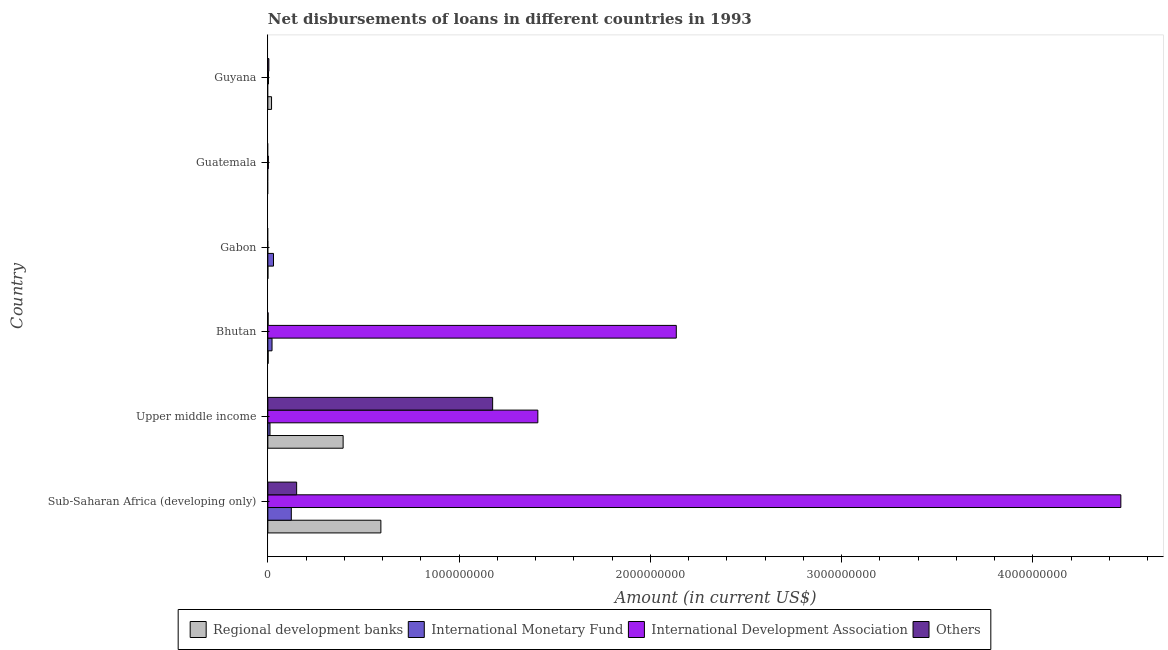How many bars are there on the 3rd tick from the top?
Ensure brevity in your answer.  2. How many bars are there on the 4th tick from the bottom?
Your response must be concise. 2. What is the label of the 2nd group of bars from the top?
Your answer should be compact. Guatemala. In how many cases, is the number of bars for a given country not equal to the number of legend labels?
Provide a short and direct response. 3. What is the amount of loan disimbursed by other organisations in Sub-Saharan Africa (developing only)?
Keep it short and to the point. 1.51e+08. Across all countries, what is the maximum amount of loan disimbursed by international development association?
Keep it short and to the point. 4.46e+09. In which country was the amount of loan disimbursed by regional development banks maximum?
Your answer should be compact. Sub-Saharan Africa (developing only). What is the total amount of loan disimbursed by other organisations in the graph?
Make the answer very short. 1.33e+09. What is the difference between the amount of loan disimbursed by international development association in Bhutan and that in Upper middle income?
Offer a terse response. 7.24e+08. What is the difference between the amount of loan disimbursed by other organisations in Bhutan and the amount of loan disimbursed by regional development banks in Guyana?
Your response must be concise. -1.81e+07. What is the average amount of loan disimbursed by other organisations per country?
Make the answer very short. 2.22e+08. What is the difference between the amount of loan disimbursed by regional development banks and amount of loan disimbursed by international development association in Guyana?
Give a very brief answer. 1.60e+07. In how many countries, is the amount of loan disimbursed by international development association greater than 4000000000 US$?
Provide a short and direct response. 1. What is the ratio of the amount of loan disimbursed by international monetary fund in Bhutan to that in Sub-Saharan Africa (developing only)?
Provide a short and direct response. 0.18. Is the amount of loan disimbursed by other organisations in Bhutan less than that in Guyana?
Offer a very short reply. Yes. What is the difference between the highest and the second highest amount of loan disimbursed by international monetary fund?
Your answer should be very brief. 9.31e+07. What is the difference between the highest and the lowest amount of loan disimbursed by international monetary fund?
Ensure brevity in your answer.  1.23e+08. In how many countries, is the amount of loan disimbursed by other organisations greater than the average amount of loan disimbursed by other organisations taken over all countries?
Your answer should be very brief. 1. Is the sum of the amount of loan disimbursed by regional development banks in Gabon and Sub-Saharan Africa (developing only) greater than the maximum amount of loan disimbursed by international monetary fund across all countries?
Your answer should be compact. Yes. Is it the case that in every country, the sum of the amount of loan disimbursed by regional development banks and amount of loan disimbursed by international monetary fund is greater than the amount of loan disimbursed by international development association?
Offer a very short reply. No. What is the difference between two consecutive major ticks on the X-axis?
Ensure brevity in your answer.  1.00e+09. Are the values on the major ticks of X-axis written in scientific E-notation?
Keep it short and to the point. No. Does the graph contain any zero values?
Provide a short and direct response. Yes. Does the graph contain grids?
Your answer should be very brief. No. What is the title of the graph?
Your response must be concise. Net disbursements of loans in different countries in 1993. What is the label or title of the Y-axis?
Your answer should be compact. Country. What is the Amount (in current US$) of Regional development banks in Sub-Saharan Africa (developing only)?
Keep it short and to the point. 5.91e+08. What is the Amount (in current US$) in International Monetary Fund in Sub-Saharan Africa (developing only)?
Make the answer very short. 1.23e+08. What is the Amount (in current US$) in International Development Association in Sub-Saharan Africa (developing only)?
Your response must be concise. 4.46e+09. What is the Amount (in current US$) of Others in Sub-Saharan Africa (developing only)?
Ensure brevity in your answer.  1.51e+08. What is the Amount (in current US$) in Regional development banks in Upper middle income?
Make the answer very short. 3.94e+08. What is the Amount (in current US$) of International Monetary Fund in Upper middle income?
Ensure brevity in your answer.  1.13e+07. What is the Amount (in current US$) of International Development Association in Upper middle income?
Give a very brief answer. 1.41e+09. What is the Amount (in current US$) in Others in Upper middle income?
Offer a very short reply. 1.18e+09. What is the Amount (in current US$) of Regional development banks in Bhutan?
Give a very brief answer. 1.58e+06. What is the Amount (in current US$) in International Monetary Fund in Bhutan?
Offer a very short reply. 2.19e+07. What is the Amount (in current US$) in International Development Association in Bhutan?
Give a very brief answer. 2.14e+09. What is the Amount (in current US$) in Others in Bhutan?
Give a very brief answer. 1.32e+06. What is the Amount (in current US$) in Regional development banks in Gabon?
Offer a terse response. 1.06e+05. What is the Amount (in current US$) in International Monetary Fund in Gabon?
Keep it short and to the point. 2.96e+07. What is the Amount (in current US$) in International Development Association in Gabon?
Your response must be concise. 0. What is the Amount (in current US$) in Others in Gabon?
Provide a succinct answer. 0. What is the Amount (in current US$) of Regional development banks in Guatemala?
Your response must be concise. 0. What is the Amount (in current US$) in International Monetary Fund in Guatemala?
Make the answer very short. 0. What is the Amount (in current US$) in International Development Association in Guatemala?
Give a very brief answer. 2.72e+06. What is the Amount (in current US$) in Others in Guatemala?
Offer a very short reply. 0. What is the Amount (in current US$) in Regional development banks in Guyana?
Make the answer very short. 1.94e+07. What is the Amount (in current US$) in International Development Association in Guyana?
Give a very brief answer. 3.42e+06. What is the Amount (in current US$) of Others in Guyana?
Provide a short and direct response. 5.28e+06. Across all countries, what is the maximum Amount (in current US$) in Regional development banks?
Provide a succinct answer. 5.91e+08. Across all countries, what is the maximum Amount (in current US$) of International Monetary Fund?
Make the answer very short. 1.23e+08. Across all countries, what is the maximum Amount (in current US$) in International Development Association?
Provide a short and direct response. 4.46e+09. Across all countries, what is the maximum Amount (in current US$) of Others?
Offer a very short reply. 1.18e+09. Across all countries, what is the minimum Amount (in current US$) in Others?
Offer a very short reply. 0. What is the total Amount (in current US$) of Regional development banks in the graph?
Your answer should be very brief. 1.01e+09. What is the total Amount (in current US$) in International Monetary Fund in the graph?
Make the answer very short. 1.85e+08. What is the total Amount (in current US$) of International Development Association in the graph?
Your answer should be very brief. 8.01e+09. What is the total Amount (in current US$) of Others in the graph?
Offer a very short reply. 1.33e+09. What is the difference between the Amount (in current US$) in Regional development banks in Sub-Saharan Africa (developing only) and that in Upper middle income?
Your answer should be compact. 1.97e+08. What is the difference between the Amount (in current US$) of International Monetary Fund in Sub-Saharan Africa (developing only) and that in Upper middle income?
Your answer should be compact. 1.11e+08. What is the difference between the Amount (in current US$) in International Development Association in Sub-Saharan Africa (developing only) and that in Upper middle income?
Your response must be concise. 3.05e+09. What is the difference between the Amount (in current US$) in Others in Sub-Saharan Africa (developing only) and that in Upper middle income?
Keep it short and to the point. -1.02e+09. What is the difference between the Amount (in current US$) of Regional development banks in Sub-Saharan Africa (developing only) and that in Bhutan?
Your answer should be compact. 5.89e+08. What is the difference between the Amount (in current US$) of International Monetary Fund in Sub-Saharan Africa (developing only) and that in Bhutan?
Your answer should be very brief. 1.01e+08. What is the difference between the Amount (in current US$) in International Development Association in Sub-Saharan Africa (developing only) and that in Bhutan?
Provide a short and direct response. 2.32e+09. What is the difference between the Amount (in current US$) of Others in Sub-Saharan Africa (developing only) and that in Bhutan?
Offer a terse response. 1.49e+08. What is the difference between the Amount (in current US$) of Regional development banks in Sub-Saharan Africa (developing only) and that in Gabon?
Keep it short and to the point. 5.91e+08. What is the difference between the Amount (in current US$) in International Monetary Fund in Sub-Saharan Africa (developing only) and that in Gabon?
Offer a very short reply. 9.31e+07. What is the difference between the Amount (in current US$) of International Development Association in Sub-Saharan Africa (developing only) and that in Guatemala?
Ensure brevity in your answer.  4.46e+09. What is the difference between the Amount (in current US$) in Regional development banks in Sub-Saharan Africa (developing only) and that in Guyana?
Offer a terse response. 5.72e+08. What is the difference between the Amount (in current US$) in International Development Association in Sub-Saharan Africa (developing only) and that in Guyana?
Your answer should be very brief. 4.46e+09. What is the difference between the Amount (in current US$) in Others in Sub-Saharan Africa (developing only) and that in Guyana?
Make the answer very short. 1.45e+08. What is the difference between the Amount (in current US$) in Regional development banks in Upper middle income and that in Bhutan?
Provide a short and direct response. 3.92e+08. What is the difference between the Amount (in current US$) in International Monetary Fund in Upper middle income and that in Bhutan?
Offer a terse response. -1.06e+07. What is the difference between the Amount (in current US$) of International Development Association in Upper middle income and that in Bhutan?
Provide a short and direct response. -7.24e+08. What is the difference between the Amount (in current US$) in Others in Upper middle income and that in Bhutan?
Provide a succinct answer. 1.17e+09. What is the difference between the Amount (in current US$) of Regional development banks in Upper middle income and that in Gabon?
Give a very brief answer. 3.93e+08. What is the difference between the Amount (in current US$) in International Monetary Fund in Upper middle income and that in Gabon?
Your response must be concise. -1.83e+07. What is the difference between the Amount (in current US$) in International Development Association in Upper middle income and that in Guatemala?
Your response must be concise. 1.41e+09. What is the difference between the Amount (in current US$) of Regional development banks in Upper middle income and that in Guyana?
Your answer should be very brief. 3.74e+08. What is the difference between the Amount (in current US$) in International Development Association in Upper middle income and that in Guyana?
Ensure brevity in your answer.  1.41e+09. What is the difference between the Amount (in current US$) in Others in Upper middle income and that in Guyana?
Offer a very short reply. 1.17e+09. What is the difference between the Amount (in current US$) in Regional development banks in Bhutan and that in Gabon?
Make the answer very short. 1.47e+06. What is the difference between the Amount (in current US$) in International Monetary Fund in Bhutan and that in Gabon?
Provide a short and direct response. -7.72e+06. What is the difference between the Amount (in current US$) in International Development Association in Bhutan and that in Guatemala?
Your answer should be very brief. 2.13e+09. What is the difference between the Amount (in current US$) in Regional development banks in Bhutan and that in Guyana?
Ensure brevity in your answer.  -1.78e+07. What is the difference between the Amount (in current US$) in International Development Association in Bhutan and that in Guyana?
Provide a short and direct response. 2.13e+09. What is the difference between the Amount (in current US$) of Others in Bhutan and that in Guyana?
Your answer should be very brief. -3.95e+06. What is the difference between the Amount (in current US$) of Regional development banks in Gabon and that in Guyana?
Offer a very short reply. -1.93e+07. What is the difference between the Amount (in current US$) in International Development Association in Guatemala and that in Guyana?
Make the answer very short. -6.98e+05. What is the difference between the Amount (in current US$) of Regional development banks in Sub-Saharan Africa (developing only) and the Amount (in current US$) of International Monetary Fund in Upper middle income?
Provide a succinct answer. 5.80e+08. What is the difference between the Amount (in current US$) of Regional development banks in Sub-Saharan Africa (developing only) and the Amount (in current US$) of International Development Association in Upper middle income?
Make the answer very short. -8.21e+08. What is the difference between the Amount (in current US$) in Regional development banks in Sub-Saharan Africa (developing only) and the Amount (in current US$) in Others in Upper middle income?
Make the answer very short. -5.84e+08. What is the difference between the Amount (in current US$) in International Monetary Fund in Sub-Saharan Africa (developing only) and the Amount (in current US$) in International Development Association in Upper middle income?
Provide a short and direct response. -1.29e+09. What is the difference between the Amount (in current US$) of International Monetary Fund in Sub-Saharan Africa (developing only) and the Amount (in current US$) of Others in Upper middle income?
Your response must be concise. -1.05e+09. What is the difference between the Amount (in current US$) in International Development Association in Sub-Saharan Africa (developing only) and the Amount (in current US$) in Others in Upper middle income?
Ensure brevity in your answer.  3.28e+09. What is the difference between the Amount (in current US$) of Regional development banks in Sub-Saharan Africa (developing only) and the Amount (in current US$) of International Monetary Fund in Bhutan?
Provide a succinct answer. 5.69e+08. What is the difference between the Amount (in current US$) in Regional development banks in Sub-Saharan Africa (developing only) and the Amount (in current US$) in International Development Association in Bhutan?
Provide a succinct answer. -1.54e+09. What is the difference between the Amount (in current US$) in Regional development banks in Sub-Saharan Africa (developing only) and the Amount (in current US$) in Others in Bhutan?
Offer a very short reply. 5.90e+08. What is the difference between the Amount (in current US$) in International Monetary Fund in Sub-Saharan Africa (developing only) and the Amount (in current US$) in International Development Association in Bhutan?
Ensure brevity in your answer.  -2.01e+09. What is the difference between the Amount (in current US$) in International Monetary Fund in Sub-Saharan Africa (developing only) and the Amount (in current US$) in Others in Bhutan?
Offer a terse response. 1.21e+08. What is the difference between the Amount (in current US$) in International Development Association in Sub-Saharan Africa (developing only) and the Amount (in current US$) in Others in Bhutan?
Ensure brevity in your answer.  4.46e+09. What is the difference between the Amount (in current US$) of Regional development banks in Sub-Saharan Africa (developing only) and the Amount (in current US$) of International Monetary Fund in Gabon?
Offer a very short reply. 5.61e+08. What is the difference between the Amount (in current US$) in Regional development banks in Sub-Saharan Africa (developing only) and the Amount (in current US$) in International Development Association in Guatemala?
Give a very brief answer. 5.88e+08. What is the difference between the Amount (in current US$) in International Monetary Fund in Sub-Saharan Africa (developing only) and the Amount (in current US$) in International Development Association in Guatemala?
Give a very brief answer. 1.20e+08. What is the difference between the Amount (in current US$) in Regional development banks in Sub-Saharan Africa (developing only) and the Amount (in current US$) in International Development Association in Guyana?
Your answer should be very brief. 5.88e+08. What is the difference between the Amount (in current US$) of Regional development banks in Sub-Saharan Africa (developing only) and the Amount (in current US$) of Others in Guyana?
Your answer should be compact. 5.86e+08. What is the difference between the Amount (in current US$) in International Monetary Fund in Sub-Saharan Africa (developing only) and the Amount (in current US$) in International Development Association in Guyana?
Make the answer very short. 1.19e+08. What is the difference between the Amount (in current US$) in International Monetary Fund in Sub-Saharan Africa (developing only) and the Amount (in current US$) in Others in Guyana?
Offer a very short reply. 1.17e+08. What is the difference between the Amount (in current US$) in International Development Association in Sub-Saharan Africa (developing only) and the Amount (in current US$) in Others in Guyana?
Your response must be concise. 4.45e+09. What is the difference between the Amount (in current US$) in Regional development banks in Upper middle income and the Amount (in current US$) in International Monetary Fund in Bhutan?
Offer a very short reply. 3.72e+08. What is the difference between the Amount (in current US$) in Regional development banks in Upper middle income and the Amount (in current US$) in International Development Association in Bhutan?
Provide a succinct answer. -1.74e+09. What is the difference between the Amount (in current US$) of Regional development banks in Upper middle income and the Amount (in current US$) of Others in Bhutan?
Ensure brevity in your answer.  3.92e+08. What is the difference between the Amount (in current US$) of International Monetary Fund in Upper middle income and the Amount (in current US$) of International Development Association in Bhutan?
Make the answer very short. -2.12e+09. What is the difference between the Amount (in current US$) of International Monetary Fund in Upper middle income and the Amount (in current US$) of Others in Bhutan?
Offer a terse response. 9.94e+06. What is the difference between the Amount (in current US$) in International Development Association in Upper middle income and the Amount (in current US$) in Others in Bhutan?
Make the answer very short. 1.41e+09. What is the difference between the Amount (in current US$) of Regional development banks in Upper middle income and the Amount (in current US$) of International Monetary Fund in Gabon?
Your answer should be very brief. 3.64e+08. What is the difference between the Amount (in current US$) of Regional development banks in Upper middle income and the Amount (in current US$) of International Development Association in Guatemala?
Your answer should be compact. 3.91e+08. What is the difference between the Amount (in current US$) in International Monetary Fund in Upper middle income and the Amount (in current US$) in International Development Association in Guatemala?
Give a very brief answer. 8.55e+06. What is the difference between the Amount (in current US$) of Regional development banks in Upper middle income and the Amount (in current US$) of International Development Association in Guyana?
Make the answer very short. 3.90e+08. What is the difference between the Amount (in current US$) in Regional development banks in Upper middle income and the Amount (in current US$) in Others in Guyana?
Provide a short and direct response. 3.88e+08. What is the difference between the Amount (in current US$) of International Monetary Fund in Upper middle income and the Amount (in current US$) of International Development Association in Guyana?
Ensure brevity in your answer.  7.85e+06. What is the difference between the Amount (in current US$) of International Monetary Fund in Upper middle income and the Amount (in current US$) of Others in Guyana?
Ensure brevity in your answer.  5.99e+06. What is the difference between the Amount (in current US$) in International Development Association in Upper middle income and the Amount (in current US$) in Others in Guyana?
Offer a terse response. 1.41e+09. What is the difference between the Amount (in current US$) of Regional development banks in Bhutan and the Amount (in current US$) of International Monetary Fund in Gabon?
Ensure brevity in your answer.  -2.80e+07. What is the difference between the Amount (in current US$) of Regional development banks in Bhutan and the Amount (in current US$) of International Development Association in Guatemala?
Offer a terse response. -1.14e+06. What is the difference between the Amount (in current US$) of International Monetary Fund in Bhutan and the Amount (in current US$) of International Development Association in Guatemala?
Provide a short and direct response. 1.91e+07. What is the difference between the Amount (in current US$) in Regional development banks in Bhutan and the Amount (in current US$) in International Development Association in Guyana?
Ensure brevity in your answer.  -1.84e+06. What is the difference between the Amount (in current US$) in Regional development banks in Bhutan and the Amount (in current US$) in Others in Guyana?
Offer a terse response. -3.70e+06. What is the difference between the Amount (in current US$) of International Monetary Fund in Bhutan and the Amount (in current US$) of International Development Association in Guyana?
Make the answer very short. 1.84e+07. What is the difference between the Amount (in current US$) in International Monetary Fund in Bhutan and the Amount (in current US$) in Others in Guyana?
Give a very brief answer. 1.66e+07. What is the difference between the Amount (in current US$) of International Development Association in Bhutan and the Amount (in current US$) of Others in Guyana?
Ensure brevity in your answer.  2.13e+09. What is the difference between the Amount (in current US$) of Regional development banks in Gabon and the Amount (in current US$) of International Development Association in Guatemala?
Your answer should be very brief. -2.62e+06. What is the difference between the Amount (in current US$) in International Monetary Fund in Gabon and the Amount (in current US$) in International Development Association in Guatemala?
Your answer should be very brief. 2.69e+07. What is the difference between the Amount (in current US$) in Regional development banks in Gabon and the Amount (in current US$) in International Development Association in Guyana?
Give a very brief answer. -3.31e+06. What is the difference between the Amount (in current US$) of Regional development banks in Gabon and the Amount (in current US$) of Others in Guyana?
Keep it short and to the point. -5.17e+06. What is the difference between the Amount (in current US$) of International Monetary Fund in Gabon and the Amount (in current US$) of International Development Association in Guyana?
Offer a terse response. 2.62e+07. What is the difference between the Amount (in current US$) of International Monetary Fund in Gabon and the Amount (in current US$) of Others in Guyana?
Your answer should be very brief. 2.43e+07. What is the difference between the Amount (in current US$) in International Development Association in Guatemala and the Amount (in current US$) in Others in Guyana?
Offer a terse response. -2.55e+06. What is the average Amount (in current US$) of Regional development banks per country?
Provide a short and direct response. 1.68e+08. What is the average Amount (in current US$) in International Monetary Fund per country?
Provide a succinct answer. 3.09e+07. What is the average Amount (in current US$) in International Development Association per country?
Offer a very short reply. 1.34e+09. What is the average Amount (in current US$) in Others per country?
Offer a very short reply. 2.22e+08. What is the difference between the Amount (in current US$) in Regional development banks and Amount (in current US$) in International Monetary Fund in Sub-Saharan Africa (developing only)?
Your answer should be compact. 4.68e+08. What is the difference between the Amount (in current US$) of Regional development banks and Amount (in current US$) of International Development Association in Sub-Saharan Africa (developing only)?
Offer a very short reply. -3.87e+09. What is the difference between the Amount (in current US$) of Regional development banks and Amount (in current US$) of Others in Sub-Saharan Africa (developing only)?
Your answer should be very brief. 4.40e+08. What is the difference between the Amount (in current US$) of International Monetary Fund and Amount (in current US$) of International Development Association in Sub-Saharan Africa (developing only)?
Your answer should be compact. -4.34e+09. What is the difference between the Amount (in current US$) in International Monetary Fund and Amount (in current US$) in Others in Sub-Saharan Africa (developing only)?
Provide a succinct answer. -2.78e+07. What is the difference between the Amount (in current US$) of International Development Association and Amount (in current US$) of Others in Sub-Saharan Africa (developing only)?
Offer a very short reply. 4.31e+09. What is the difference between the Amount (in current US$) in Regional development banks and Amount (in current US$) in International Monetary Fund in Upper middle income?
Your answer should be very brief. 3.82e+08. What is the difference between the Amount (in current US$) of Regional development banks and Amount (in current US$) of International Development Association in Upper middle income?
Provide a succinct answer. -1.02e+09. What is the difference between the Amount (in current US$) in Regional development banks and Amount (in current US$) in Others in Upper middle income?
Provide a short and direct response. -7.82e+08. What is the difference between the Amount (in current US$) in International Monetary Fund and Amount (in current US$) in International Development Association in Upper middle income?
Provide a succinct answer. -1.40e+09. What is the difference between the Amount (in current US$) in International Monetary Fund and Amount (in current US$) in Others in Upper middle income?
Your response must be concise. -1.16e+09. What is the difference between the Amount (in current US$) of International Development Association and Amount (in current US$) of Others in Upper middle income?
Give a very brief answer. 2.36e+08. What is the difference between the Amount (in current US$) of Regional development banks and Amount (in current US$) of International Monetary Fund in Bhutan?
Keep it short and to the point. -2.03e+07. What is the difference between the Amount (in current US$) of Regional development banks and Amount (in current US$) of International Development Association in Bhutan?
Offer a terse response. -2.13e+09. What is the difference between the Amount (in current US$) of Regional development banks and Amount (in current US$) of Others in Bhutan?
Give a very brief answer. 2.52e+05. What is the difference between the Amount (in current US$) in International Monetary Fund and Amount (in current US$) in International Development Association in Bhutan?
Offer a very short reply. -2.11e+09. What is the difference between the Amount (in current US$) of International Monetary Fund and Amount (in current US$) of Others in Bhutan?
Offer a very short reply. 2.05e+07. What is the difference between the Amount (in current US$) in International Development Association and Amount (in current US$) in Others in Bhutan?
Ensure brevity in your answer.  2.13e+09. What is the difference between the Amount (in current US$) of Regional development banks and Amount (in current US$) of International Monetary Fund in Gabon?
Provide a short and direct response. -2.95e+07. What is the difference between the Amount (in current US$) in Regional development banks and Amount (in current US$) in International Development Association in Guyana?
Your answer should be very brief. 1.60e+07. What is the difference between the Amount (in current US$) in Regional development banks and Amount (in current US$) in Others in Guyana?
Your answer should be very brief. 1.41e+07. What is the difference between the Amount (in current US$) in International Development Association and Amount (in current US$) in Others in Guyana?
Offer a terse response. -1.86e+06. What is the ratio of the Amount (in current US$) in Regional development banks in Sub-Saharan Africa (developing only) to that in Upper middle income?
Ensure brevity in your answer.  1.5. What is the ratio of the Amount (in current US$) in International Monetary Fund in Sub-Saharan Africa (developing only) to that in Upper middle income?
Keep it short and to the point. 10.89. What is the ratio of the Amount (in current US$) in International Development Association in Sub-Saharan Africa (developing only) to that in Upper middle income?
Ensure brevity in your answer.  3.16. What is the ratio of the Amount (in current US$) of Others in Sub-Saharan Africa (developing only) to that in Upper middle income?
Your response must be concise. 0.13. What is the ratio of the Amount (in current US$) of Regional development banks in Sub-Saharan Africa (developing only) to that in Bhutan?
Give a very brief answer. 374.99. What is the ratio of the Amount (in current US$) of International Monetary Fund in Sub-Saharan Africa (developing only) to that in Bhutan?
Provide a short and direct response. 5.61. What is the ratio of the Amount (in current US$) in International Development Association in Sub-Saharan Africa (developing only) to that in Bhutan?
Offer a terse response. 2.09. What is the ratio of the Amount (in current US$) in Others in Sub-Saharan Africa (developing only) to that in Bhutan?
Your answer should be very brief. 113.69. What is the ratio of the Amount (in current US$) in Regional development banks in Sub-Saharan Africa (developing only) to that in Gabon?
Ensure brevity in your answer.  5575.29. What is the ratio of the Amount (in current US$) in International Monetary Fund in Sub-Saharan Africa (developing only) to that in Gabon?
Ensure brevity in your answer.  4.15. What is the ratio of the Amount (in current US$) in International Development Association in Sub-Saharan Africa (developing only) to that in Guatemala?
Keep it short and to the point. 1639.03. What is the ratio of the Amount (in current US$) of Regional development banks in Sub-Saharan Africa (developing only) to that in Guyana?
Offer a terse response. 30.48. What is the ratio of the Amount (in current US$) in International Development Association in Sub-Saharan Africa (developing only) to that in Guyana?
Make the answer very short. 1304.42. What is the ratio of the Amount (in current US$) of Others in Sub-Saharan Africa (developing only) to that in Guyana?
Provide a succinct answer. 28.53. What is the ratio of the Amount (in current US$) in Regional development banks in Upper middle income to that in Bhutan?
Keep it short and to the point. 249.73. What is the ratio of the Amount (in current US$) in International Monetary Fund in Upper middle income to that in Bhutan?
Ensure brevity in your answer.  0.52. What is the ratio of the Amount (in current US$) of International Development Association in Upper middle income to that in Bhutan?
Keep it short and to the point. 0.66. What is the ratio of the Amount (in current US$) in Others in Upper middle income to that in Bhutan?
Ensure brevity in your answer.  887.71. What is the ratio of the Amount (in current US$) of Regional development banks in Upper middle income to that in Gabon?
Offer a terse response. 3712.96. What is the ratio of the Amount (in current US$) of International Monetary Fund in Upper middle income to that in Gabon?
Ensure brevity in your answer.  0.38. What is the ratio of the Amount (in current US$) in International Development Association in Upper middle income to that in Guatemala?
Give a very brief answer. 518.81. What is the ratio of the Amount (in current US$) of Regional development banks in Upper middle income to that in Guyana?
Your answer should be compact. 20.3. What is the ratio of the Amount (in current US$) of International Development Association in Upper middle income to that in Guyana?
Offer a very short reply. 412.89. What is the ratio of the Amount (in current US$) of Others in Upper middle income to that in Guyana?
Your answer should be compact. 222.81. What is the ratio of the Amount (in current US$) in Regional development banks in Bhutan to that in Gabon?
Keep it short and to the point. 14.87. What is the ratio of the Amount (in current US$) in International Monetary Fund in Bhutan to that in Gabon?
Provide a succinct answer. 0.74. What is the ratio of the Amount (in current US$) of International Development Association in Bhutan to that in Guatemala?
Ensure brevity in your answer.  784.83. What is the ratio of the Amount (in current US$) of Regional development banks in Bhutan to that in Guyana?
Your answer should be compact. 0.08. What is the ratio of the Amount (in current US$) in International Development Association in Bhutan to that in Guyana?
Make the answer very short. 624.6. What is the ratio of the Amount (in current US$) of Others in Bhutan to that in Guyana?
Your answer should be compact. 0.25. What is the ratio of the Amount (in current US$) of Regional development banks in Gabon to that in Guyana?
Provide a short and direct response. 0.01. What is the ratio of the Amount (in current US$) of International Development Association in Guatemala to that in Guyana?
Your answer should be compact. 0.8. What is the difference between the highest and the second highest Amount (in current US$) of Regional development banks?
Your response must be concise. 1.97e+08. What is the difference between the highest and the second highest Amount (in current US$) in International Monetary Fund?
Offer a terse response. 9.31e+07. What is the difference between the highest and the second highest Amount (in current US$) of International Development Association?
Provide a short and direct response. 2.32e+09. What is the difference between the highest and the second highest Amount (in current US$) of Others?
Ensure brevity in your answer.  1.02e+09. What is the difference between the highest and the lowest Amount (in current US$) of Regional development banks?
Ensure brevity in your answer.  5.91e+08. What is the difference between the highest and the lowest Amount (in current US$) of International Monetary Fund?
Keep it short and to the point. 1.23e+08. What is the difference between the highest and the lowest Amount (in current US$) in International Development Association?
Provide a succinct answer. 4.46e+09. What is the difference between the highest and the lowest Amount (in current US$) of Others?
Your response must be concise. 1.18e+09. 